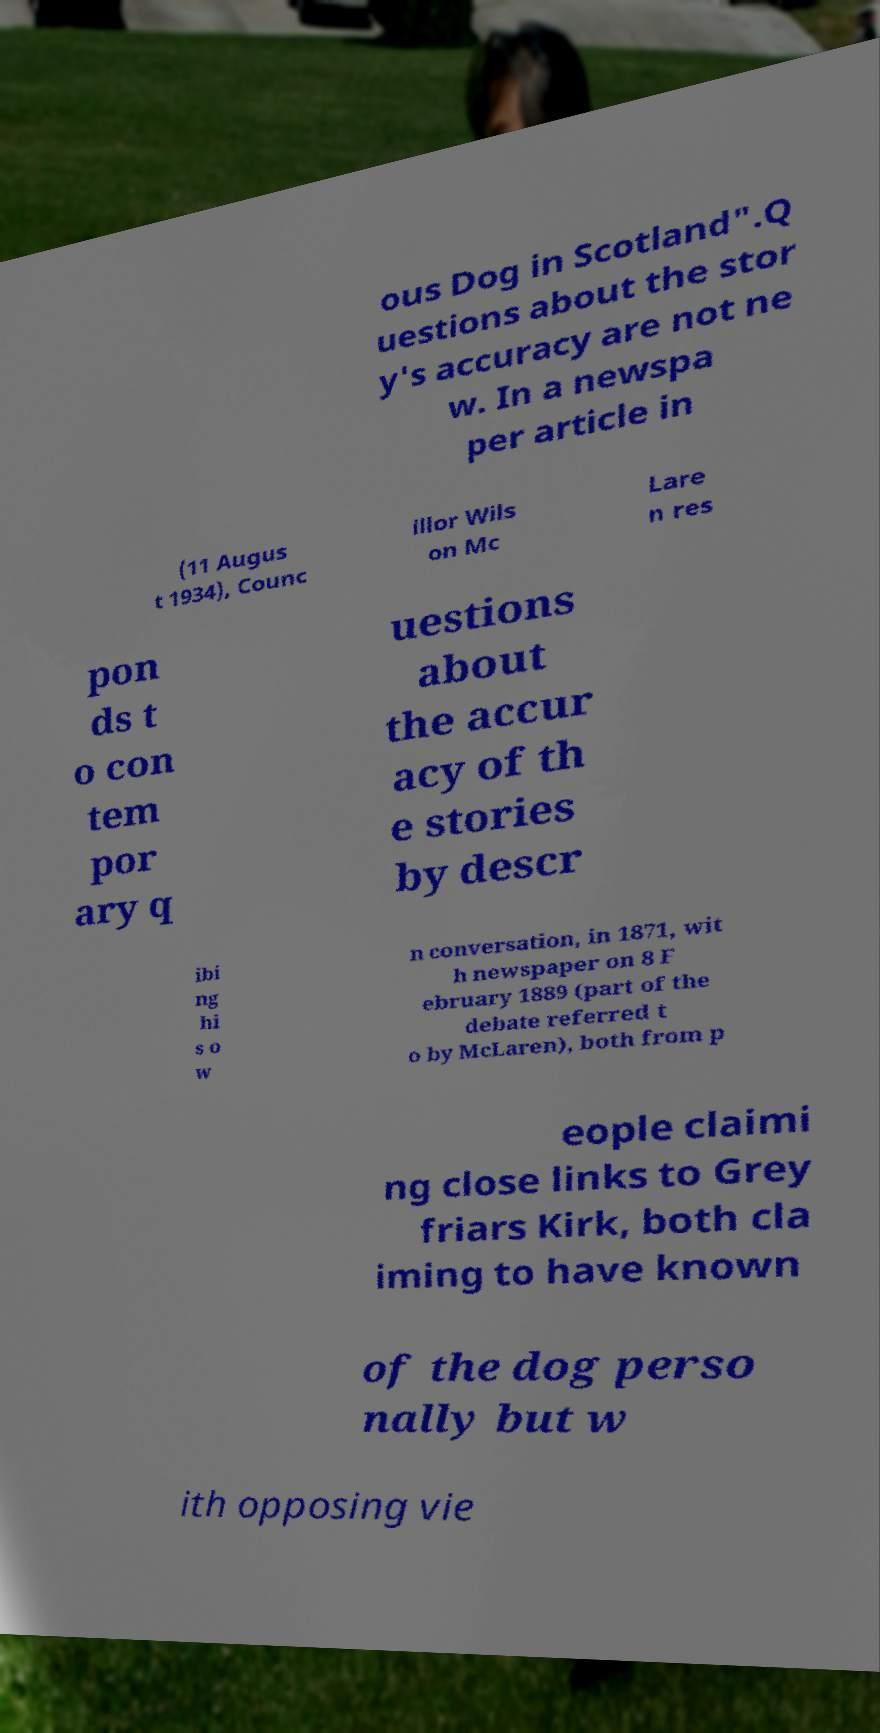What messages or text are displayed in this image? I need them in a readable, typed format. ous Dog in Scotland".Q uestions about the stor y's accuracy are not ne w. In a newspa per article in (11 Augus t 1934), Counc illor Wils on Mc Lare n res pon ds t o con tem por ary q uestions about the accur acy of th e stories by descr ibi ng hi s o w n conversation, in 1871, wit h newspaper on 8 F ebruary 1889 (part of the debate referred t o by McLaren), both from p eople claimi ng close links to Grey friars Kirk, both cla iming to have known of the dog perso nally but w ith opposing vie 